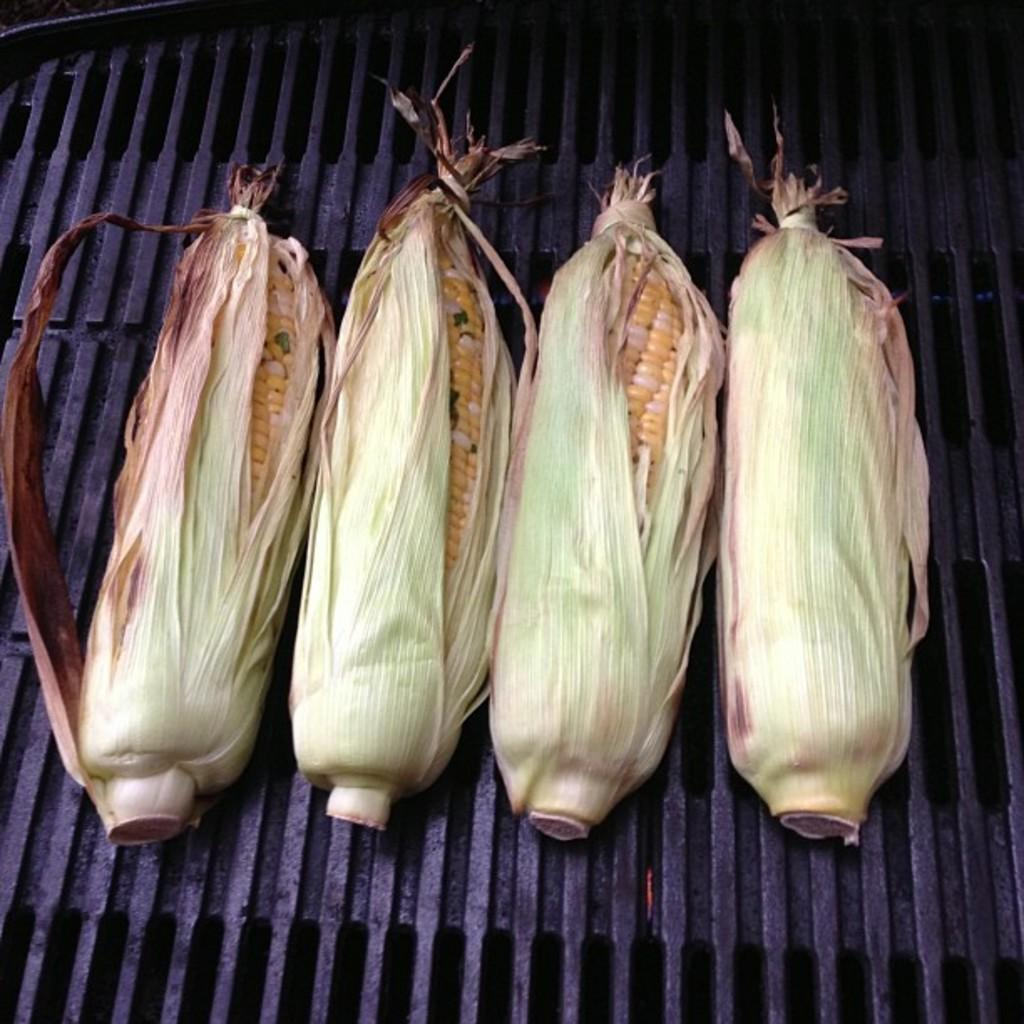How many corners can be identified in the image? There are four corners in the image. What is placed on the barbecue in the image? Peel is placed on a barbecue in the image. What type of memory is being used to store the image? The question about memory is not relevant to the image, as it does not contain any information about the storage or recording of the image. What scientific principles are being demonstrated in the image? The image does not depict any scientific principles or experiments; it simply shows peel on a barbecue. 